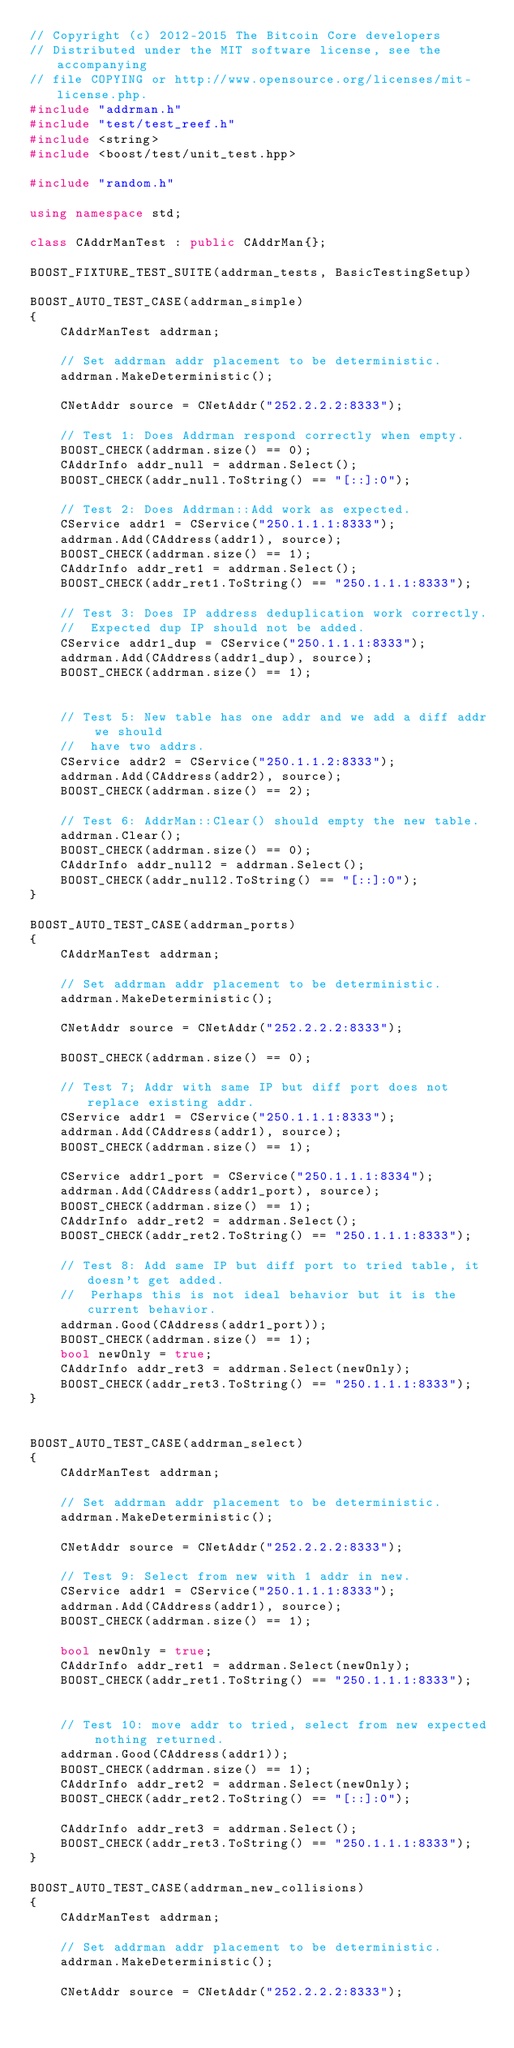<code> <loc_0><loc_0><loc_500><loc_500><_C++_>// Copyright (c) 2012-2015 The Bitcoin Core developers
// Distributed under the MIT software license, see the accompanying
// file COPYING or http://www.opensource.org/licenses/mit-license.php.
#include "addrman.h"
#include "test/test_reef.h"
#include <string>
#include <boost/test/unit_test.hpp>

#include "random.h"

using namespace std;

class CAddrManTest : public CAddrMan{};

BOOST_FIXTURE_TEST_SUITE(addrman_tests, BasicTestingSetup)

BOOST_AUTO_TEST_CASE(addrman_simple)
{
    CAddrManTest addrman;

    // Set addrman addr placement to be deterministic.
    addrman.MakeDeterministic();

    CNetAddr source = CNetAddr("252.2.2.2:8333");

    // Test 1: Does Addrman respond correctly when empty.
    BOOST_CHECK(addrman.size() == 0);
    CAddrInfo addr_null = addrman.Select();
    BOOST_CHECK(addr_null.ToString() == "[::]:0");

    // Test 2: Does Addrman::Add work as expected.
    CService addr1 = CService("250.1.1.1:8333");
    addrman.Add(CAddress(addr1), source);
    BOOST_CHECK(addrman.size() == 1);
    CAddrInfo addr_ret1 = addrman.Select();
    BOOST_CHECK(addr_ret1.ToString() == "250.1.1.1:8333");

    // Test 3: Does IP address deduplication work correctly. 
    //  Expected dup IP should not be added.
    CService addr1_dup = CService("250.1.1.1:8333");
    addrman.Add(CAddress(addr1_dup), source);
    BOOST_CHECK(addrman.size() == 1);


    // Test 5: New table has one addr and we add a diff addr we should
    //  have two addrs.
    CService addr2 = CService("250.1.1.2:8333");
    addrman.Add(CAddress(addr2), source);
    BOOST_CHECK(addrman.size() == 2);

    // Test 6: AddrMan::Clear() should empty the new table. 
    addrman.Clear();
    BOOST_CHECK(addrman.size() == 0);
    CAddrInfo addr_null2 = addrman.Select();
    BOOST_CHECK(addr_null2.ToString() == "[::]:0");
}

BOOST_AUTO_TEST_CASE(addrman_ports)
{
    CAddrManTest addrman;

    // Set addrman addr placement to be deterministic.
    addrman.MakeDeterministic();

    CNetAddr source = CNetAddr("252.2.2.2:8333");

    BOOST_CHECK(addrman.size() == 0);

    // Test 7; Addr with same IP but diff port does not replace existing addr.
    CService addr1 = CService("250.1.1.1:8333");
    addrman.Add(CAddress(addr1), source);
    BOOST_CHECK(addrman.size() == 1);

    CService addr1_port = CService("250.1.1.1:8334");
    addrman.Add(CAddress(addr1_port), source);
    BOOST_CHECK(addrman.size() == 1);
    CAddrInfo addr_ret2 = addrman.Select();
    BOOST_CHECK(addr_ret2.ToString() == "250.1.1.1:8333");

    // Test 8: Add same IP but diff port to tried table, it doesn't get added.
    //  Perhaps this is not ideal behavior but it is the current behavior.
    addrman.Good(CAddress(addr1_port));
    BOOST_CHECK(addrman.size() == 1);
    bool newOnly = true;
    CAddrInfo addr_ret3 = addrman.Select(newOnly);
    BOOST_CHECK(addr_ret3.ToString() == "250.1.1.1:8333");
}


BOOST_AUTO_TEST_CASE(addrman_select)
{
    CAddrManTest addrman;

    // Set addrman addr placement to be deterministic.
    addrman.MakeDeterministic();

    CNetAddr source = CNetAddr("252.2.2.2:8333");

    // Test 9: Select from new with 1 addr in new.
    CService addr1 = CService("250.1.1.1:8333");
    addrman.Add(CAddress(addr1), source);
    BOOST_CHECK(addrman.size() == 1);

    bool newOnly = true;
    CAddrInfo addr_ret1 = addrman.Select(newOnly);
    BOOST_CHECK(addr_ret1.ToString() == "250.1.1.1:8333");


    // Test 10: move addr to tried, select from new expected nothing returned.
    addrman.Good(CAddress(addr1));
    BOOST_CHECK(addrman.size() == 1);
    CAddrInfo addr_ret2 = addrman.Select(newOnly);
    BOOST_CHECK(addr_ret2.ToString() == "[::]:0");

    CAddrInfo addr_ret3 = addrman.Select();
    BOOST_CHECK(addr_ret3.ToString() == "250.1.1.1:8333");
}

BOOST_AUTO_TEST_CASE(addrman_new_collisions)
{
    CAddrManTest addrman;

    // Set addrman addr placement to be deterministic.
    addrman.MakeDeterministic();

    CNetAddr source = CNetAddr("252.2.2.2:8333");
</code> 